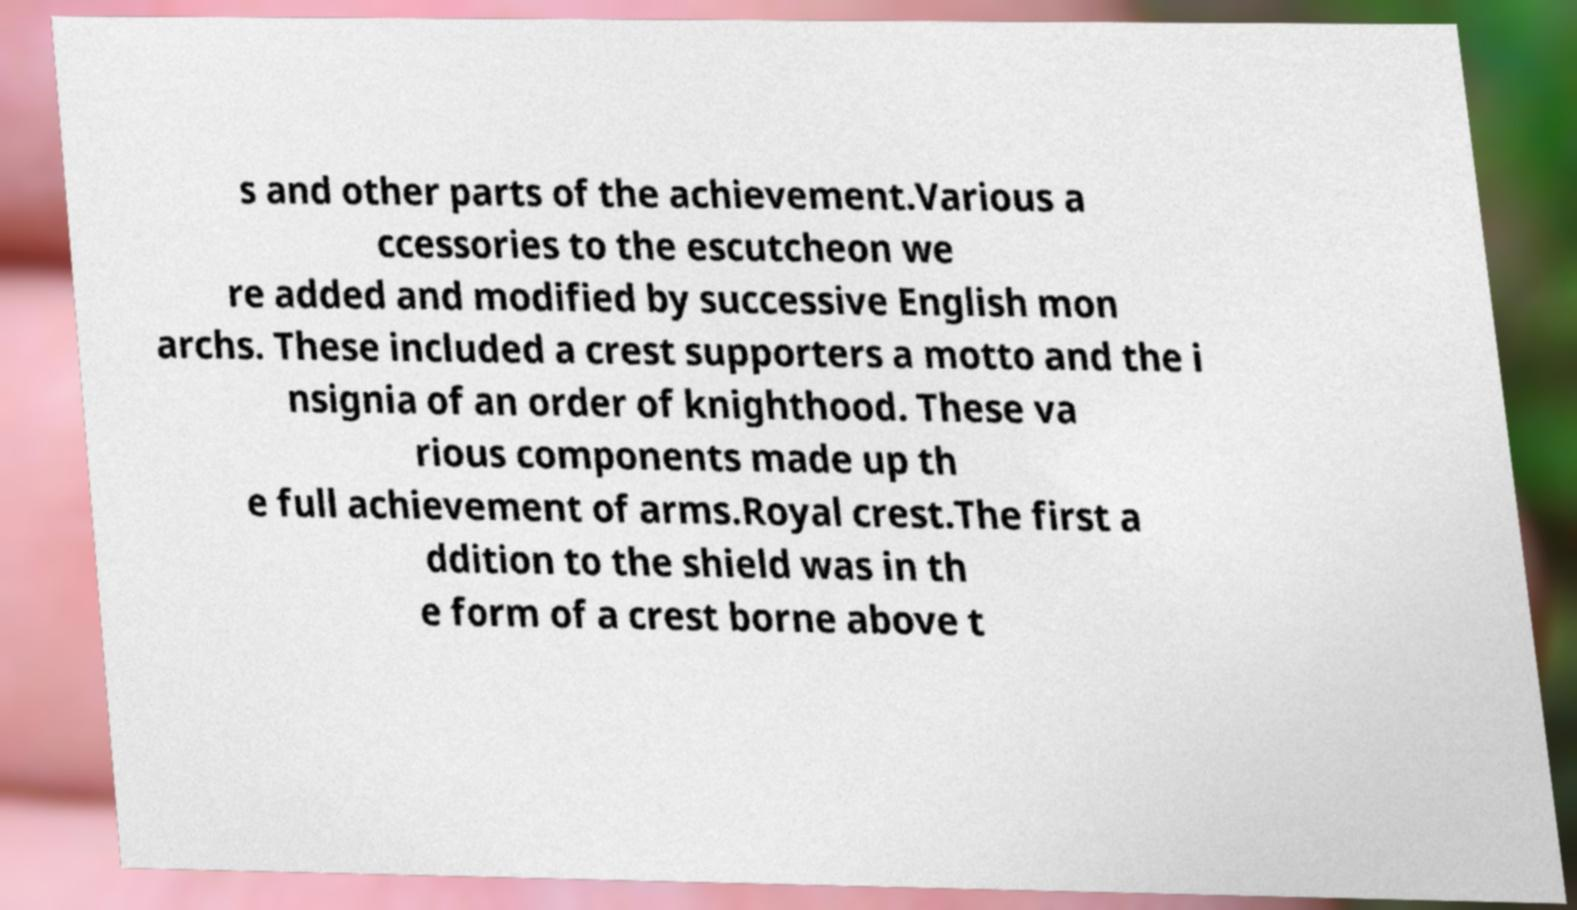For documentation purposes, I need the text within this image transcribed. Could you provide that? s and other parts of the achievement.Various a ccessories to the escutcheon we re added and modified by successive English mon archs. These included a crest supporters a motto and the i nsignia of an order of knighthood. These va rious components made up th e full achievement of arms.Royal crest.The first a ddition to the shield was in th e form of a crest borne above t 